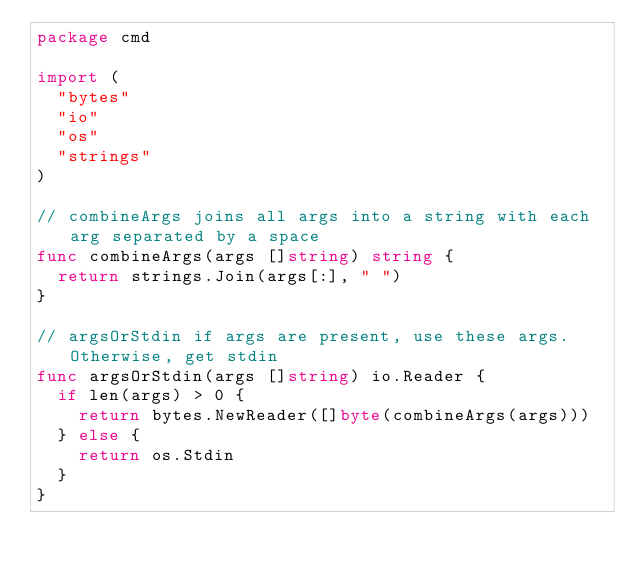<code> <loc_0><loc_0><loc_500><loc_500><_Go_>package cmd

import (
	"bytes"
	"io"
	"os"
	"strings"
)

// combineArgs joins all args into a string with each arg separated by a space
func combineArgs(args []string) string {
	return strings.Join(args[:], " ")
}

// argsOrStdin if args are present, use these args. Otherwise, get stdin
func argsOrStdin(args []string) io.Reader {
	if len(args) > 0 {
		return bytes.NewReader([]byte(combineArgs(args)))
	} else {
		return os.Stdin
	}
}
</code> 